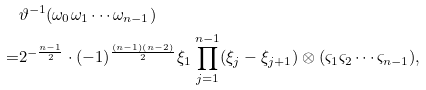Convert formula to latex. <formula><loc_0><loc_0><loc_500><loc_500>& \vartheta ^ { - 1 } ( \omega _ { 0 } \omega _ { 1 } \cdots \omega _ { n - 1 } ) \\ = & 2 ^ { - \frac { n - 1 } 2 } \cdot ( - 1 ) ^ { \frac { ( n - 1 ) ( n - 2 ) } { 2 } } \xi _ { 1 } \prod _ { j = 1 } ^ { n - 1 } ( \xi _ { j } - \xi _ { j + 1 } ) \otimes ( \varsigma _ { 1 } \varsigma _ { 2 } \cdots \varsigma _ { n - 1 } ) ,</formula> 